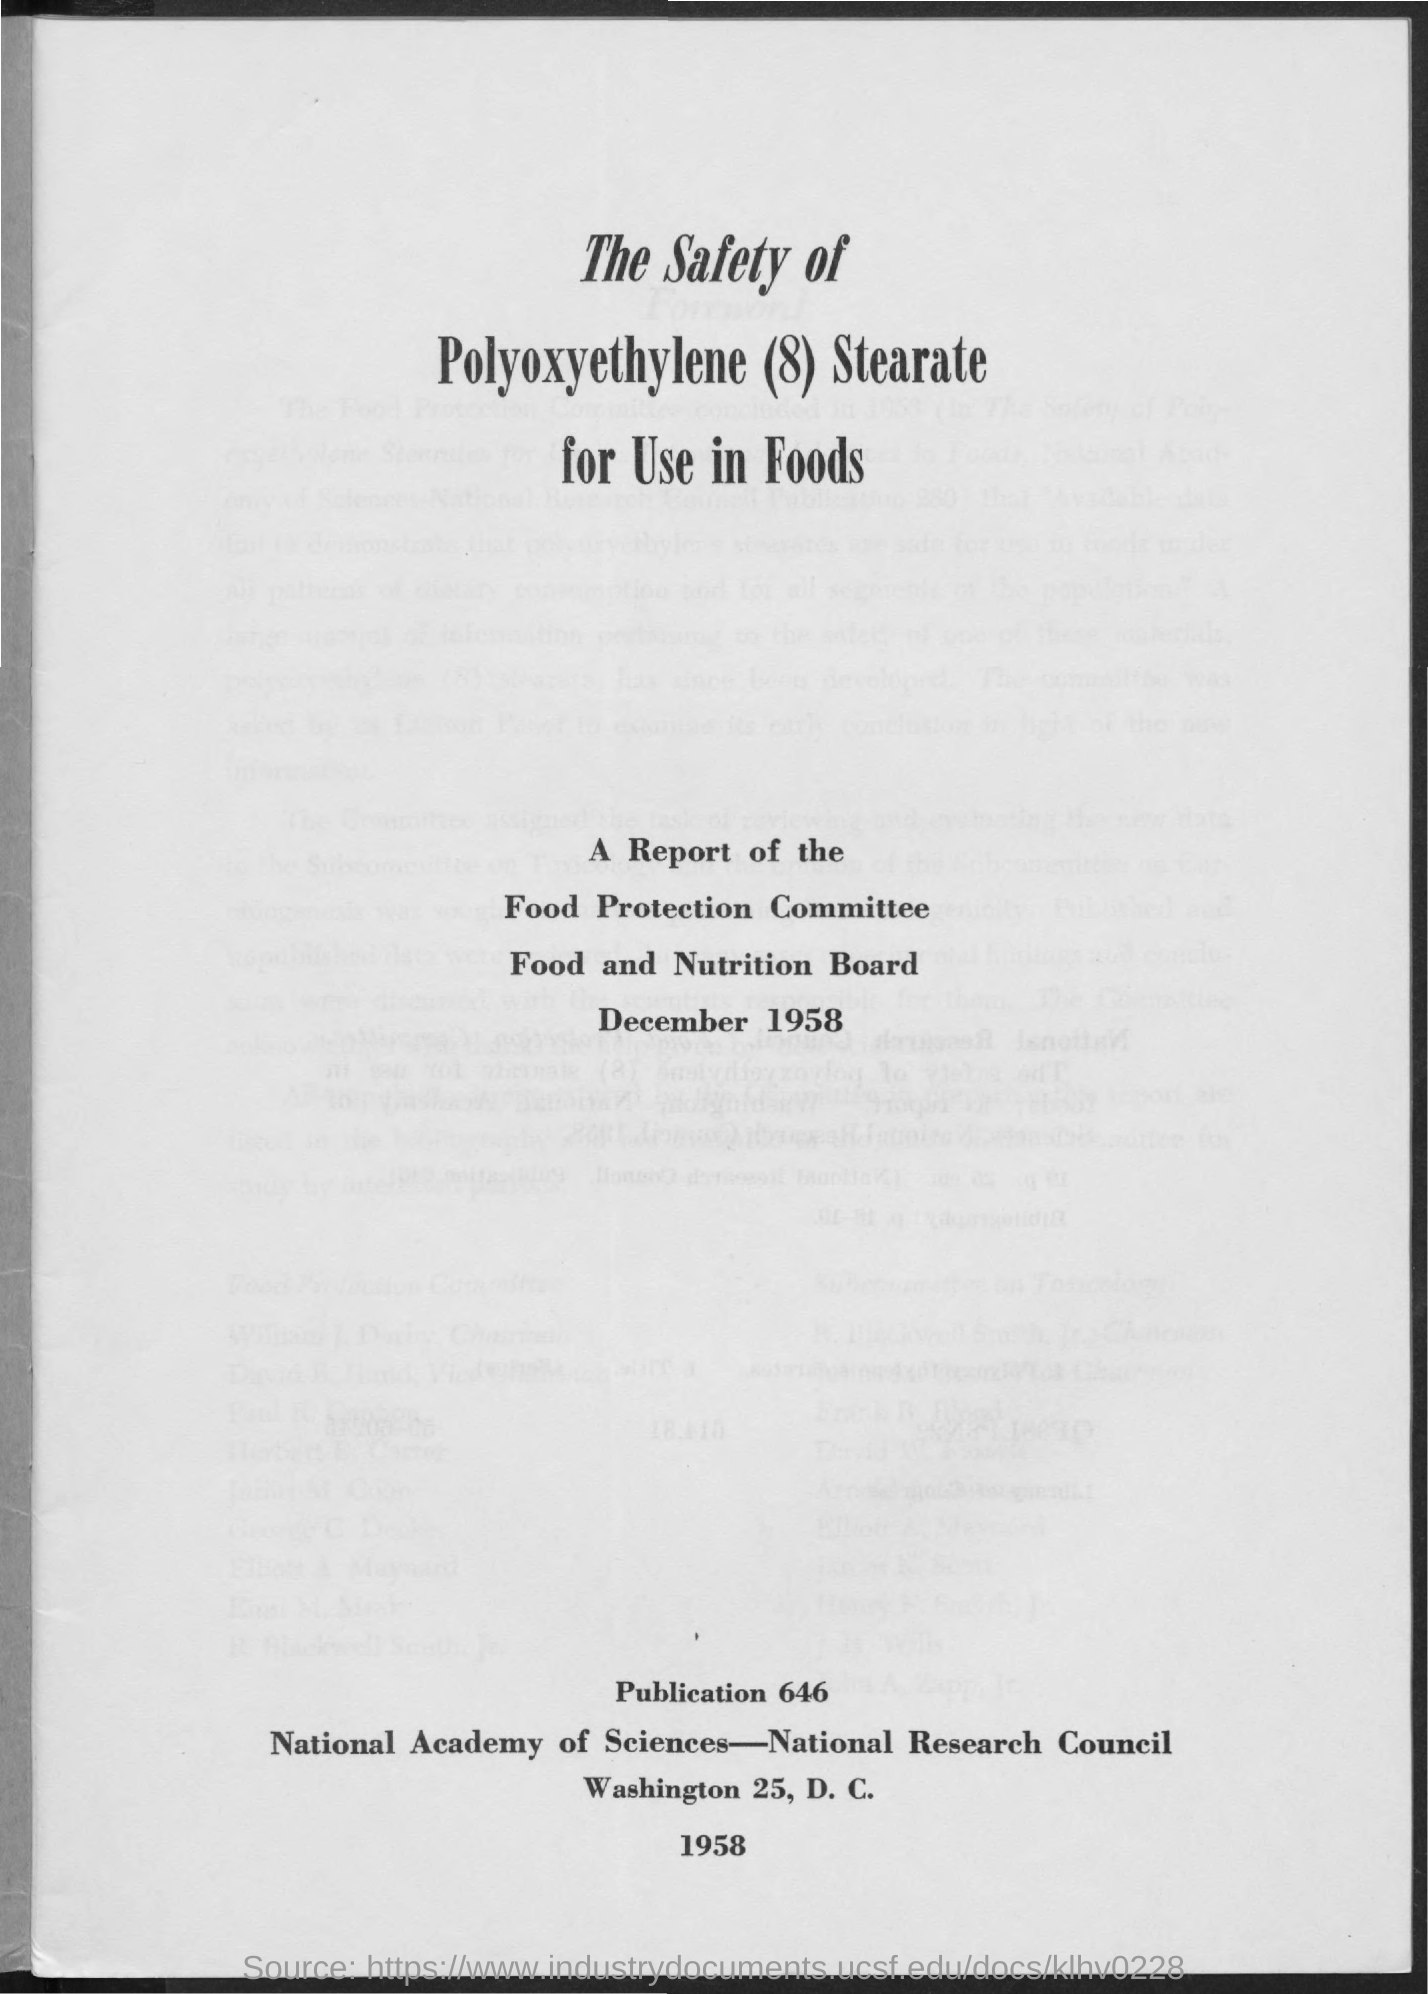Point out several critical features in this image. The title of the report is "The Safety of Polyoxyethylene (8) Stearate for Use in Foods. The publication number is 646.. The report was dated in December 1958. 